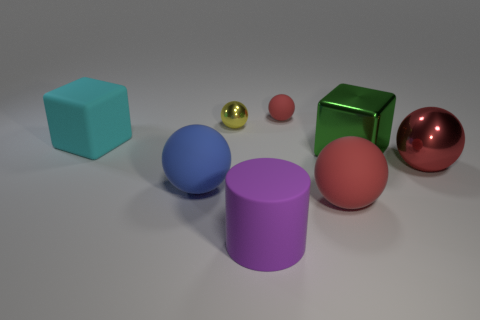How many objects are in this image, and can you categorize them by shape? There are six objects in this image. They can be categorized by shape as follows: two cubes (one green and one light blue), two spheres (one gold and one red), one cylinder (purple), and one smaller sphere or ball-like object (pink). Which of these shapes is not as commonly found in everyday objects? The cylinder is a less common shape in everyday objects compared to cubes and spheres, as most day-to-day items tend to be boxy or spheroidal for practical reasons such as storage and handling. 